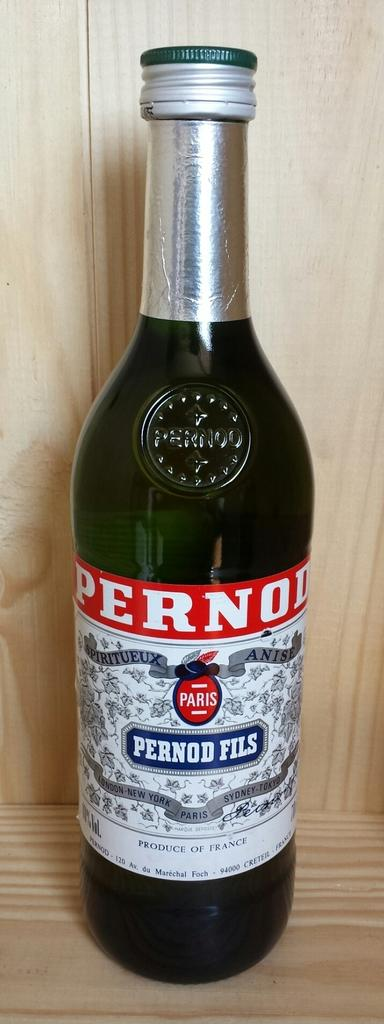<image>
Describe the image concisely. A dark green glass bottle of Pernod Fils alcohol with white label and silver screw on cap. 